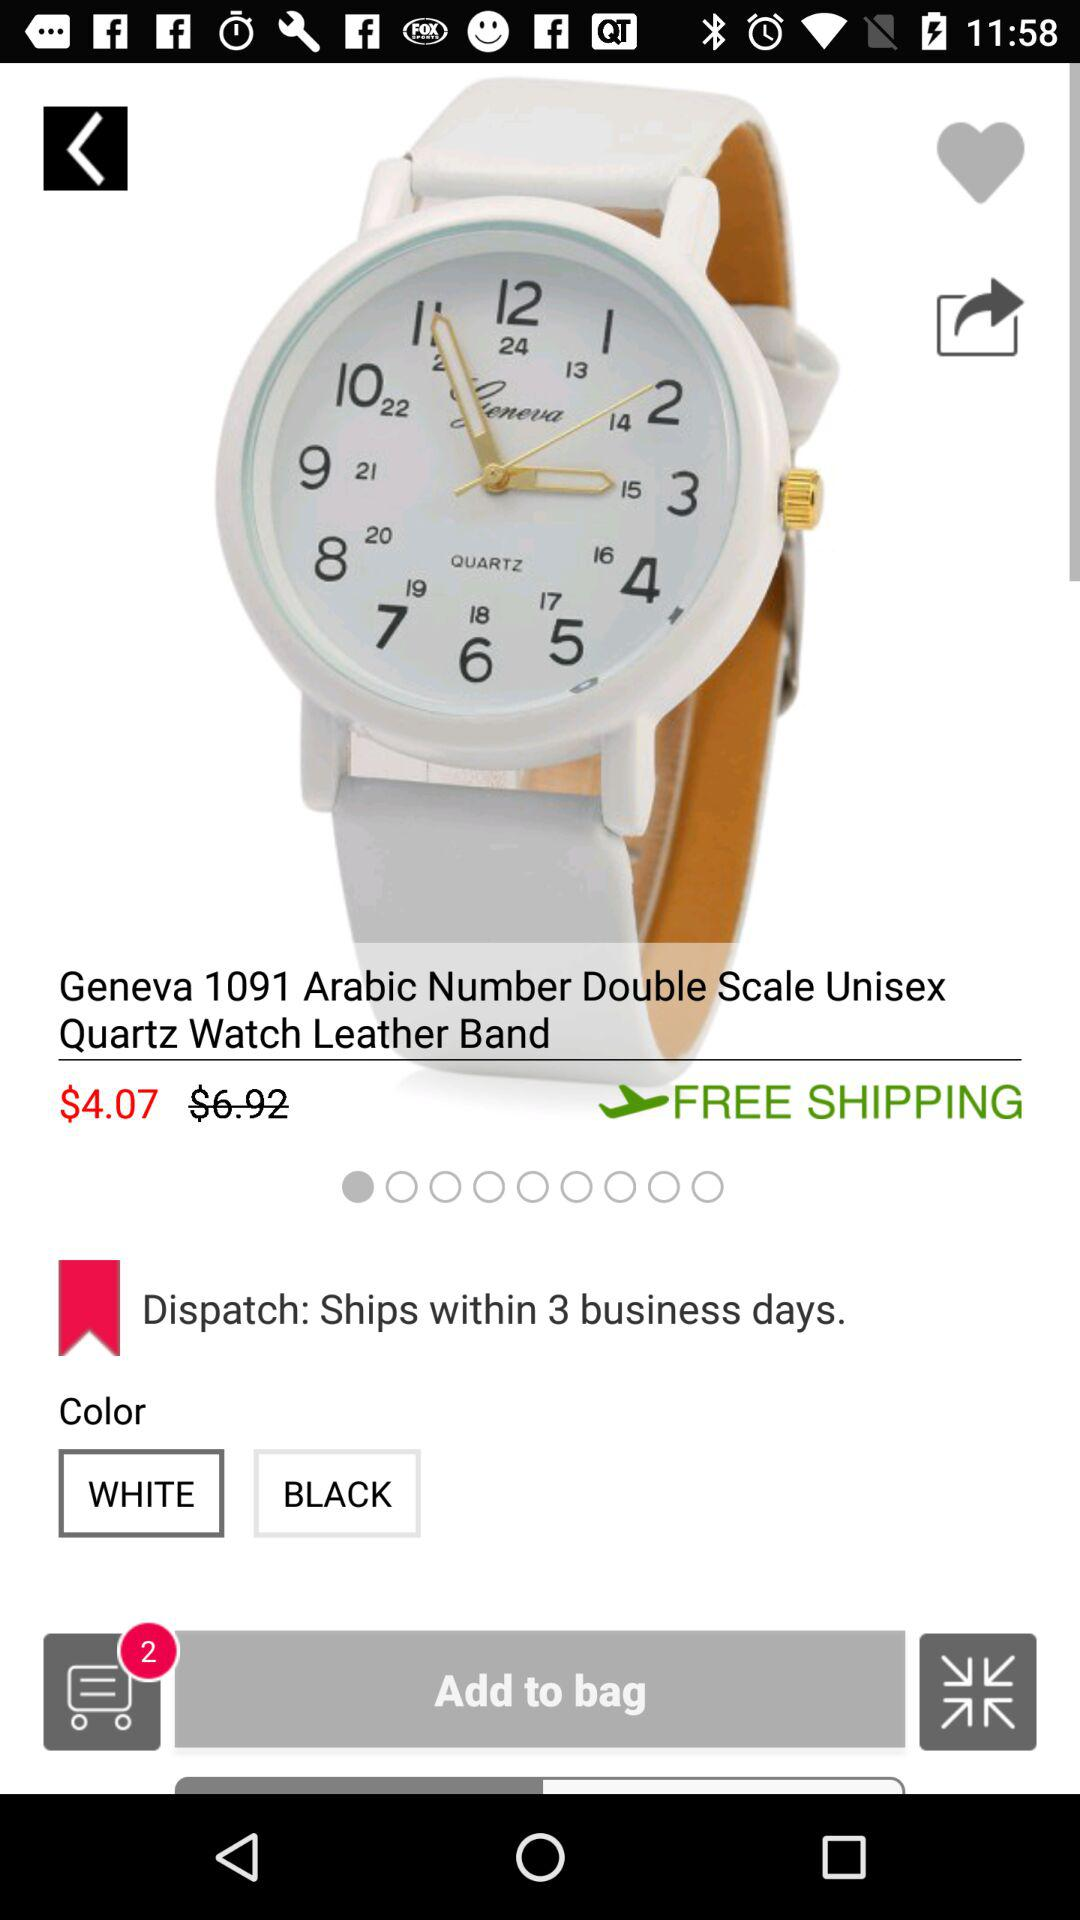What is the shipping charge? The shipping charge is free. 